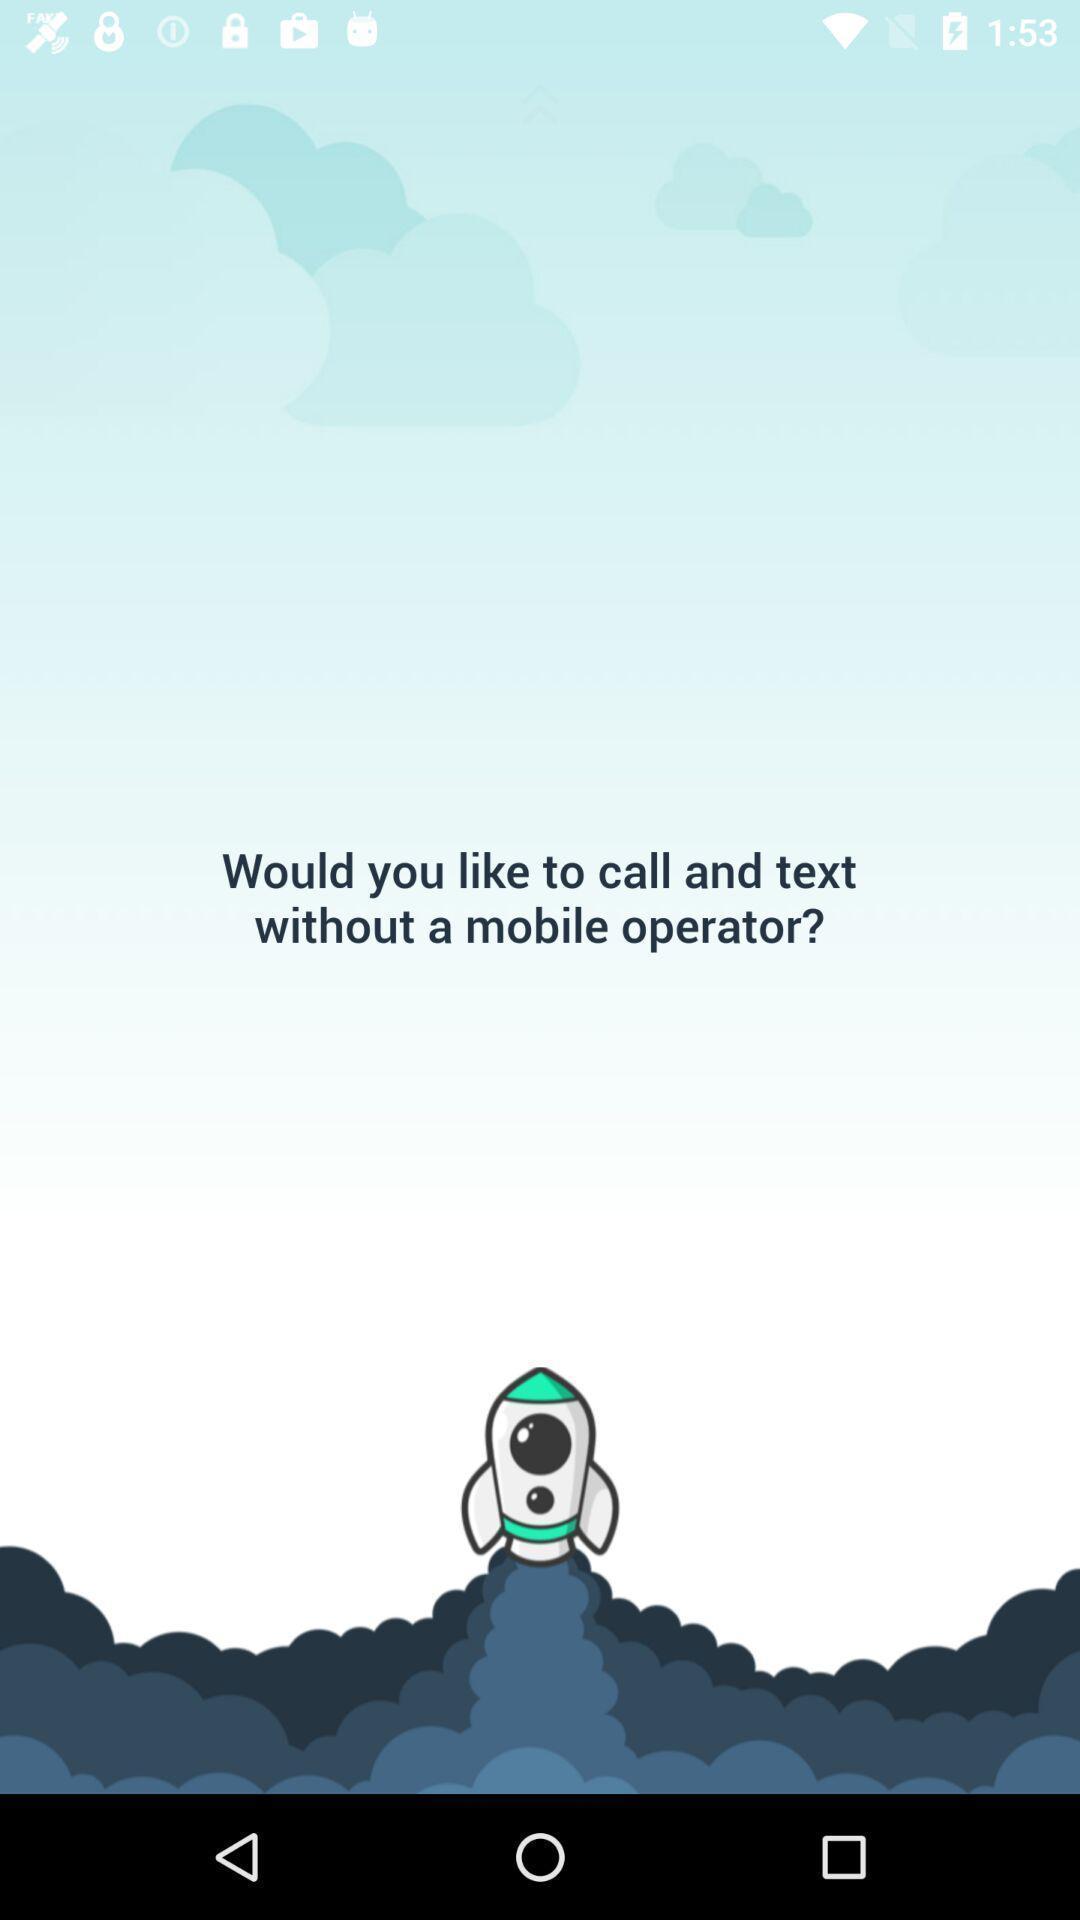Tell me about the visual elements in this screen capture. Screen shows call and text without mobile operator in app. 